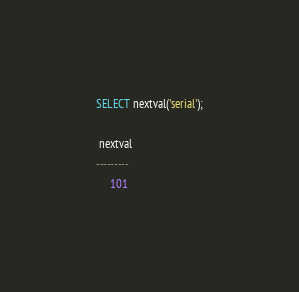Convert code to text. <code><loc_0><loc_0><loc_500><loc_500><_SQL_>SELECT nextval('serial');

 nextval
---------
     101
</code> 